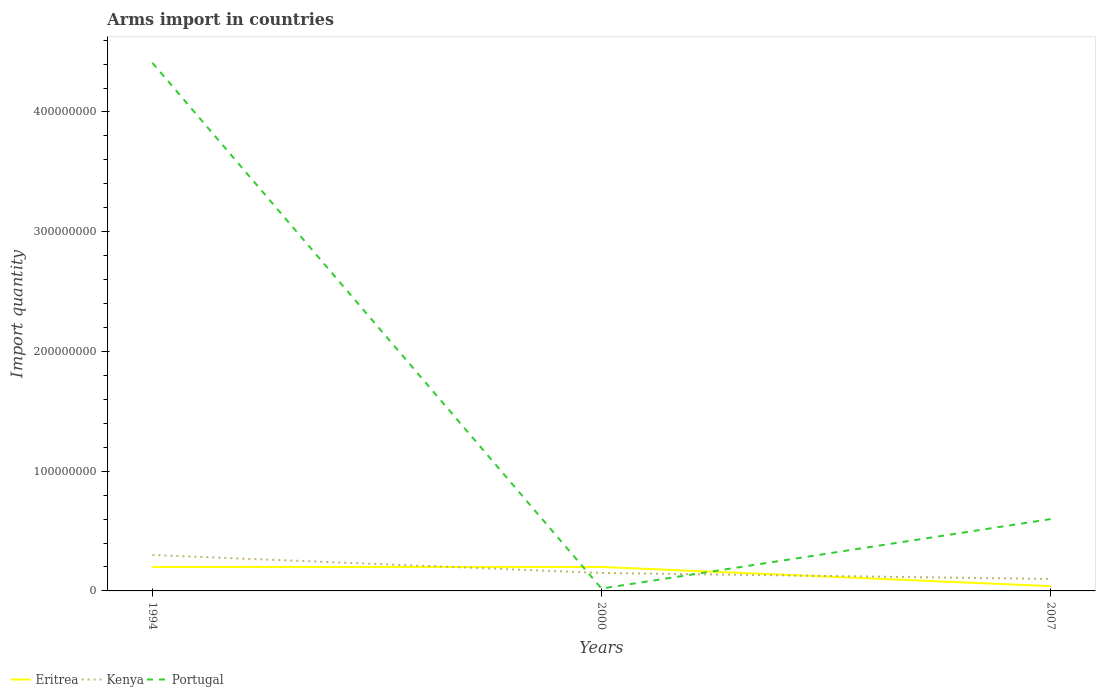How many different coloured lines are there?
Your answer should be very brief. 3. In which year was the total arms import in Portugal maximum?
Your answer should be compact. 2000. What is the total total arms import in Eritrea in the graph?
Provide a short and direct response. 1.60e+07. What is the difference between the highest and the second highest total arms import in Eritrea?
Provide a short and direct response. 1.60e+07. What is the difference between the highest and the lowest total arms import in Kenya?
Offer a terse response. 1. Does the graph contain any zero values?
Provide a short and direct response. No. Does the graph contain grids?
Ensure brevity in your answer.  No. Where does the legend appear in the graph?
Your answer should be compact. Bottom left. How are the legend labels stacked?
Make the answer very short. Horizontal. What is the title of the graph?
Your answer should be very brief. Arms import in countries. What is the label or title of the Y-axis?
Your answer should be very brief. Import quantity. What is the Import quantity of Eritrea in 1994?
Your answer should be very brief. 2.00e+07. What is the Import quantity in Kenya in 1994?
Keep it short and to the point. 3.00e+07. What is the Import quantity of Portugal in 1994?
Make the answer very short. 4.41e+08. What is the Import quantity of Kenya in 2000?
Give a very brief answer. 1.50e+07. What is the Import quantity of Portugal in 2000?
Provide a succinct answer. 2.00e+06. What is the Import quantity in Eritrea in 2007?
Offer a terse response. 4.00e+06. What is the Import quantity of Kenya in 2007?
Give a very brief answer. 1.00e+07. What is the Import quantity in Portugal in 2007?
Your answer should be compact. 6.00e+07. Across all years, what is the maximum Import quantity of Eritrea?
Offer a terse response. 2.00e+07. Across all years, what is the maximum Import quantity in Kenya?
Offer a very short reply. 3.00e+07. Across all years, what is the maximum Import quantity in Portugal?
Offer a very short reply. 4.41e+08. What is the total Import quantity in Eritrea in the graph?
Provide a succinct answer. 4.40e+07. What is the total Import quantity of Kenya in the graph?
Make the answer very short. 5.50e+07. What is the total Import quantity in Portugal in the graph?
Give a very brief answer. 5.03e+08. What is the difference between the Import quantity of Eritrea in 1994 and that in 2000?
Your response must be concise. 0. What is the difference between the Import quantity in Kenya in 1994 and that in 2000?
Make the answer very short. 1.50e+07. What is the difference between the Import quantity of Portugal in 1994 and that in 2000?
Make the answer very short. 4.39e+08. What is the difference between the Import quantity in Eritrea in 1994 and that in 2007?
Keep it short and to the point. 1.60e+07. What is the difference between the Import quantity of Portugal in 1994 and that in 2007?
Provide a succinct answer. 3.81e+08. What is the difference between the Import quantity in Eritrea in 2000 and that in 2007?
Your answer should be compact. 1.60e+07. What is the difference between the Import quantity of Portugal in 2000 and that in 2007?
Your answer should be compact. -5.80e+07. What is the difference between the Import quantity in Eritrea in 1994 and the Import quantity in Portugal in 2000?
Give a very brief answer. 1.80e+07. What is the difference between the Import quantity of Kenya in 1994 and the Import quantity of Portugal in 2000?
Your answer should be very brief. 2.80e+07. What is the difference between the Import quantity in Eritrea in 1994 and the Import quantity in Portugal in 2007?
Provide a short and direct response. -4.00e+07. What is the difference between the Import quantity of Kenya in 1994 and the Import quantity of Portugal in 2007?
Give a very brief answer. -3.00e+07. What is the difference between the Import quantity of Eritrea in 2000 and the Import quantity of Portugal in 2007?
Provide a short and direct response. -4.00e+07. What is the difference between the Import quantity of Kenya in 2000 and the Import quantity of Portugal in 2007?
Offer a very short reply. -4.50e+07. What is the average Import quantity in Eritrea per year?
Offer a terse response. 1.47e+07. What is the average Import quantity of Kenya per year?
Keep it short and to the point. 1.83e+07. What is the average Import quantity in Portugal per year?
Your answer should be very brief. 1.68e+08. In the year 1994, what is the difference between the Import quantity of Eritrea and Import quantity of Kenya?
Ensure brevity in your answer.  -1.00e+07. In the year 1994, what is the difference between the Import quantity of Eritrea and Import quantity of Portugal?
Ensure brevity in your answer.  -4.21e+08. In the year 1994, what is the difference between the Import quantity of Kenya and Import quantity of Portugal?
Provide a short and direct response. -4.11e+08. In the year 2000, what is the difference between the Import quantity of Eritrea and Import quantity of Kenya?
Provide a succinct answer. 5.00e+06. In the year 2000, what is the difference between the Import quantity of Eritrea and Import quantity of Portugal?
Provide a succinct answer. 1.80e+07. In the year 2000, what is the difference between the Import quantity of Kenya and Import quantity of Portugal?
Offer a terse response. 1.30e+07. In the year 2007, what is the difference between the Import quantity in Eritrea and Import quantity in Kenya?
Offer a very short reply. -6.00e+06. In the year 2007, what is the difference between the Import quantity in Eritrea and Import quantity in Portugal?
Offer a very short reply. -5.60e+07. In the year 2007, what is the difference between the Import quantity in Kenya and Import quantity in Portugal?
Your answer should be compact. -5.00e+07. What is the ratio of the Import quantity of Eritrea in 1994 to that in 2000?
Give a very brief answer. 1. What is the ratio of the Import quantity in Portugal in 1994 to that in 2000?
Offer a terse response. 220.5. What is the ratio of the Import quantity of Portugal in 1994 to that in 2007?
Make the answer very short. 7.35. What is the ratio of the Import quantity of Eritrea in 2000 to that in 2007?
Provide a succinct answer. 5. What is the ratio of the Import quantity in Kenya in 2000 to that in 2007?
Ensure brevity in your answer.  1.5. What is the ratio of the Import quantity in Portugal in 2000 to that in 2007?
Keep it short and to the point. 0.03. What is the difference between the highest and the second highest Import quantity of Eritrea?
Give a very brief answer. 0. What is the difference between the highest and the second highest Import quantity of Kenya?
Your answer should be very brief. 1.50e+07. What is the difference between the highest and the second highest Import quantity of Portugal?
Make the answer very short. 3.81e+08. What is the difference between the highest and the lowest Import quantity of Eritrea?
Keep it short and to the point. 1.60e+07. What is the difference between the highest and the lowest Import quantity of Portugal?
Your response must be concise. 4.39e+08. 